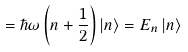Convert formula to latex. <formula><loc_0><loc_0><loc_500><loc_500>= \hbar { \omega } \left ( n + \frac { 1 } { 2 } \right ) \left | n \right \rangle = E _ { n } \left | n \right \rangle</formula> 